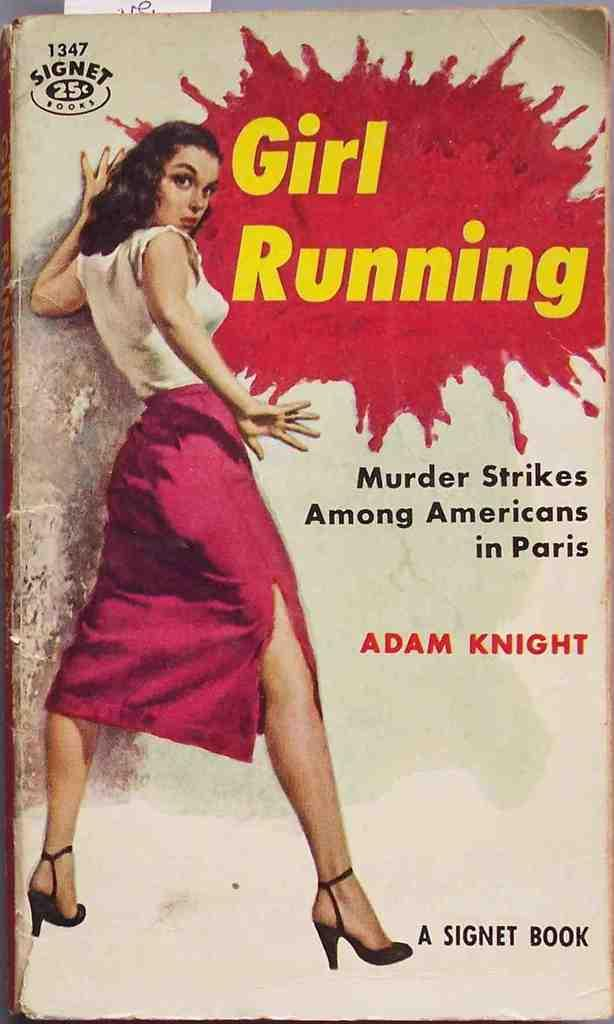Provide a one-sentence caption for the provided image. A book by Adam Knight sells for $0.25. 